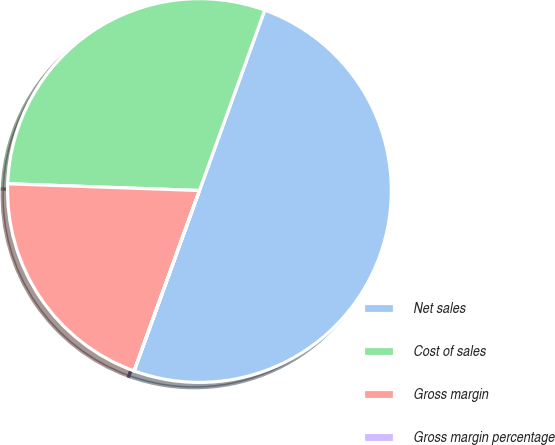Convert chart to OTSL. <chart><loc_0><loc_0><loc_500><loc_500><pie_chart><fcel>Net sales<fcel>Cost of sales<fcel>Gross margin<fcel>Gross margin percentage<nl><fcel>50.0%<fcel>29.97%<fcel>20.03%<fcel>0.01%<nl></chart> 